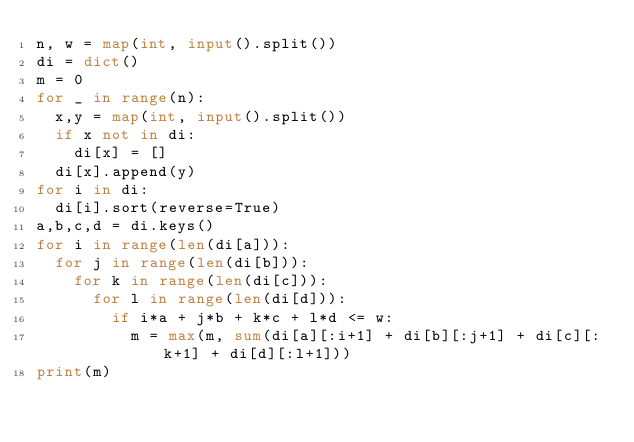Convert code to text. <code><loc_0><loc_0><loc_500><loc_500><_Python_>n, w = map(int, input().split())
di = dict()
m = 0
for _ in range(n):
  x,y = map(int, input().split())
  if x not in di:
    di[x] = []
  di[x].append(y)
for i in di:
  di[i].sort(reverse=True)
a,b,c,d = di.keys()
for i in range(len(di[a])):
  for j in range(len(di[b])):
    for k in range(len(di[c])):
      for l in range(len(di[d])):
        if i*a + j*b + k*c + l*d <= w:
          m = max(m, sum(di[a][:i+1] + di[b][:j+1] + di[c][:k+1] + di[d][:l+1]))
print(m)</code> 